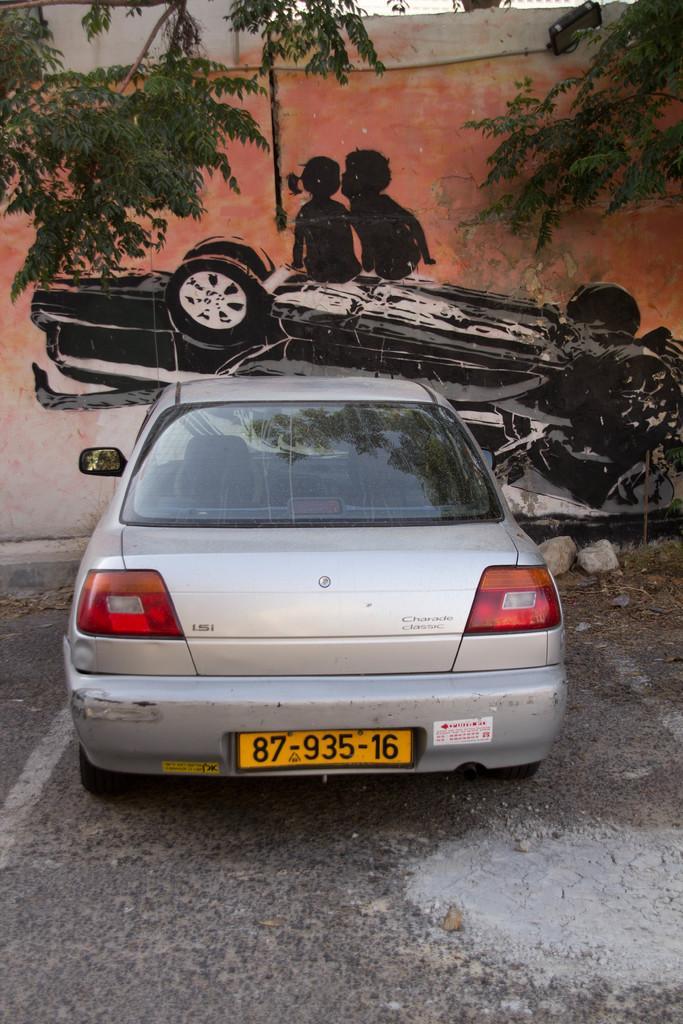Please provide a concise description of this image. In this image I can see the vehicle on the road. In the background I can see the trees and the painting on the wall. I can see the painting of two people and vehicle. 